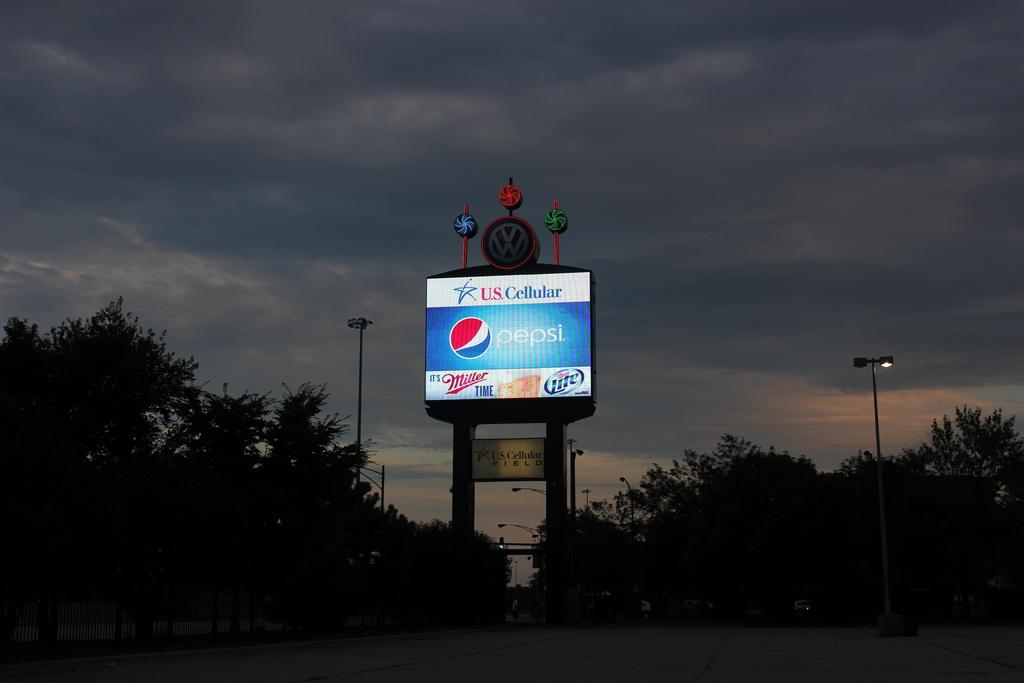Provide a one-sentence caption for the provided image. a Pepsi billboard sponsored by US Cellular lit up in the dark. 